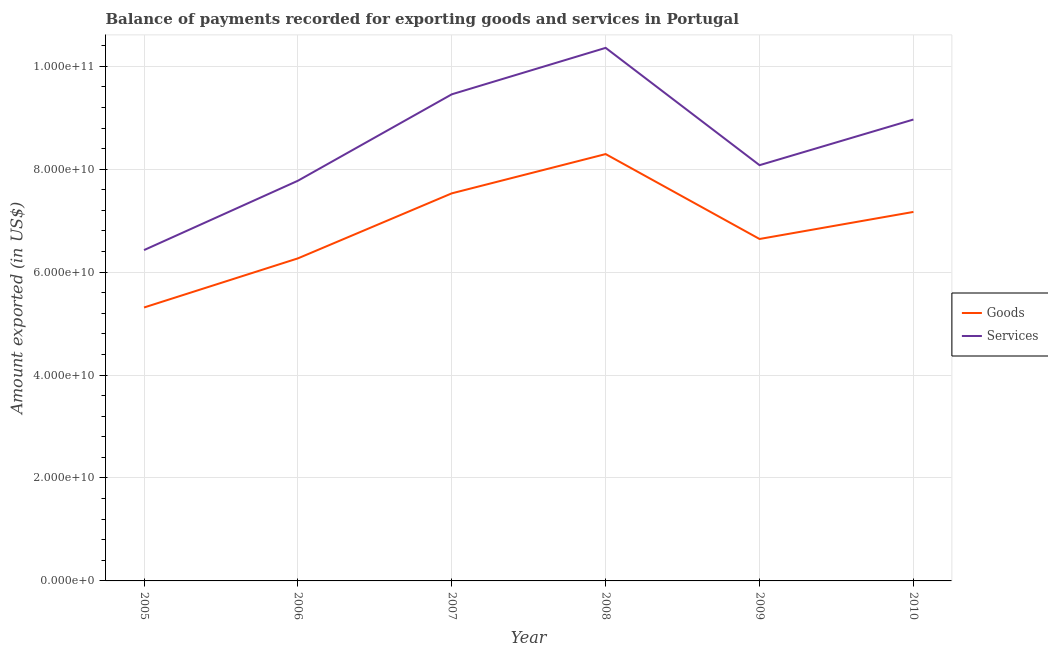How many different coloured lines are there?
Provide a succinct answer. 2. Does the line corresponding to amount of services exported intersect with the line corresponding to amount of goods exported?
Ensure brevity in your answer.  No. What is the amount of goods exported in 2005?
Give a very brief answer. 5.31e+1. Across all years, what is the maximum amount of goods exported?
Offer a very short reply. 8.29e+1. Across all years, what is the minimum amount of goods exported?
Offer a very short reply. 5.31e+1. In which year was the amount of goods exported minimum?
Provide a short and direct response. 2005. What is the total amount of services exported in the graph?
Your answer should be compact. 5.11e+11. What is the difference between the amount of services exported in 2006 and that in 2008?
Give a very brief answer. -2.58e+1. What is the difference between the amount of services exported in 2010 and the amount of goods exported in 2008?
Ensure brevity in your answer.  6.71e+09. What is the average amount of services exported per year?
Ensure brevity in your answer.  8.51e+1. In the year 2005, what is the difference between the amount of goods exported and amount of services exported?
Your response must be concise. -1.12e+1. In how many years, is the amount of services exported greater than 92000000000 US$?
Offer a terse response. 2. What is the ratio of the amount of services exported in 2008 to that in 2010?
Provide a succinct answer. 1.16. Is the difference between the amount of services exported in 2007 and 2009 greater than the difference between the amount of goods exported in 2007 and 2009?
Your answer should be compact. Yes. What is the difference between the highest and the second highest amount of services exported?
Offer a terse response. 9.03e+09. What is the difference between the highest and the lowest amount of services exported?
Offer a very short reply. 3.93e+1. Does the amount of services exported monotonically increase over the years?
Your answer should be compact. No. Is the amount of goods exported strictly greater than the amount of services exported over the years?
Your answer should be compact. No. How many lines are there?
Your answer should be compact. 2. Does the graph contain any zero values?
Your answer should be very brief. No. Does the graph contain grids?
Provide a short and direct response. Yes. Where does the legend appear in the graph?
Ensure brevity in your answer.  Center right. How many legend labels are there?
Keep it short and to the point. 2. How are the legend labels stacked?
Ensure brevity in your answer.  Vertical. What is the title of the graph?
Provide a succinct answer. Balance of payments recorded for exporting goods and services in Portugal. What is the label or title of the Y-axis?
Make the answer very short. Amount exported (in US$). What is the Amount exported (in US$) of Goods in 2005?
Offer a very short reply. 5.31e+1. What is the Amount exported (in US$) in Services in 2005?
Your answer should be very brief. 6.43e+1. What is the Amount exported (in US$) in Goods in 2006?
Your answer should be very brief. 6.27e+1. What is the Amount exported (in US$) of Services in 2006?
Provide a succinct answer. 7.78e+1. What is the Amount exported (in US$) of Goods in 2007?
Make the answer very short. 7.53e+1. What is the Amount exported (in US$) of Services in 2007?
Provide a short and direct response. 9.45e+1. What is the Amount exported (in US$) in Goods in 2008?
Provide a short and direct response. 8.29e+1. What is the Amount exported (in US$) in Services in 2008?
Keep it short and to the point. 1.04e+11. What is the Amount exported (in US$) in Goods in 2009?
Provide a succinct answer. 6.64e+1. What is the Amount exported (in US$) of Services in 2009?
Make the answer very short. 8.08e+1. What is the Amount exported (in US$) in Goods in 2010?
Provide a succinct answer. 7.17e+1. What is the Amount exported (in US$) of Services in 2010?
Your answer should be compact. 8.96e+1. Across all years, what is the maximum Amount exported (in US$) of Goods?
Make the answer very short. 8.29e+1. Across all years, what is the maximum Amount exported (in US$) in Services?
Your response must be concise. 1.04e+11. Across all years, what is the minimum Amount exported (in US$) in Goods?
Give a very brief answer. 5.31e+1. Across all years, what is the minimum Amount exported (in US$) in Services?
Keep it short and to the point. 6.43e+1. What is the total Amount exported (in US$) of Goods in the graph?
Your answer should be very brief. 4.12e+11. What is the total Amount exported (in US$) of Services in the graph?
Your answer should be compact. 5.11e+11. What is the difference between the Amount exported (in US$) of Goods in 2005 and that in 2006?
Offer a very short reply. -9.54e+09. What is the difference between the Amount exported (in US$) in Services in 2005 and that in 2006?
Your answer should be compact. -1.35e+1. What is the difference between the Amount exported (in US$) of Goods in 2005 and that in 2007?
Offer a very short reply. -2.22e+1. What is the difference between the Amount exported (in US$) in Services in 2005 and that in 2007?
Keep it short and to the point. -3.03e+1. What is the difference between the Amount exported (in US$) in Goods in 2005 and that in 2008?
Make the answer very short. -2.98e+1. What is the difference between the Amount exported (in US$) of Services in 2005 and that in 2008?
Ensure brevity in your answer.  -3.93e+1. What is the difference between the Amount exported (in US$) of Goods in 2005 and that in 2009?
Make the answer very short. -1.33e+1. What is the difference between the Amount exported (in US$) of Services in 2005 and that in 2009?
Keep it short and to the point. -1.65e+1. What is the difference between the Amount exported (in US$) in Goods in 2005 and that in 2010?
Your response must be concise. -1.86e+1. What is the difference between the Amount exported (in US$) in Services in 2005 and that in 2010?
Provide a short and direct response. -2.54e+1. What is the difference between the Amount exported (in US$) in Goods in 2006 and that in 2007?
Your answer should be very brief. -1.26e+1. What is the difference between the Amount exported (in US$) in Services in 2006 and that in 2007?
Ensure brevity in your answer.  -1.68e+1. What is the difference between the Amount exported (in US$) of Goods in 2006 and that in 2008?
Your answer should be very brief. -2.03e+1. What is the difference between the Amount exported (in US$) in Services in 2006 and that in 2008?
Your answer should be compact. -2.58e+1. What is the difference between the Amount exported (in US$) of Goods in 2006 and that in 2009?
Give a very brief answer. -3.77e+09. What is the difference between the Amount exported (in US$) in Services in 2006 and that in 2009?
Give a very brief answer. -3.02e+09. What is the difference between the Amount exported (in US$) in Goods in 2006 and that in 2010?
Ensure brevity in your answer.  -9.03e+09. What is the difference between the Amount exported (in US$) in Services in 2006 and that in 2010?
Your answer should be very brief. -1.19e+1. What is the difference between the Amount exported (in US$) of Goods in 2007 and that in 2008?
Keep it short and to the point. -7.63e+09. What is the difference between the Amount exported (in US$) of Services in 2007 and that in 2008?
Keep it short and to the point. -9.03e+09. What is the difference between the Amount exported (in US$) of Goods in 2007 and that in 2009?
Your response must be concise. 8.87e+09. What is the difference between the Amount exported (in US$) in Services in 2007 and that in 2009?
Provide a succinct answer. 1.38e+1. What is the difference between the Amount exported (in US$) in Goods in 2007 and that in 2010?
Your answer should be compact. 3.61e+09. What is the difference between the Amount exported (in US$) of Services in 2007 and that in 2010?
Provide a short and direct response. 4.90e+09. What is the difference between the Amount exported (in US$) of Goods in 2008 and that in 2009?
Keep it short and to the point. 1.65e+1. What is the difference between the Amount exported (in US$) in Services in 2008 and that in 2009?
Provide a short and direct response. 2.28e+1. What is the difference between the Amount exported (in US$) in Goods in 2008 and that in 2010?
Ensure brevity in your answer.  1.12e+1. What is the difference between the Amount exported (in US$) in Services in 2008 and that in 2010?
Your answer should be compact. 1.39e+1. What is the difference between the Amount exported (in US$) of Goods in 2009 and that in 2010?
Your answer should be compact. -5.26e+09. What is the difference between the Amount exported (in US$) in Services in 2009 and that in 2010?
Provide a succinct answer. -8.87e+09. What is the difference between the Amount exported (in US$) of Goods in 2005 and the Amount exported (in US$) of Services in 2006?
Offer a terse response. -2.46e+1. What is the difference between the Amount exported (in US$) in Goods in 2005 and the Amount exported (in US$) in Services in 2007?
Make the answer very short. -4.14e+1. What is the difference between the Amount exported (in US$) in Goods in 2005 and the Amount exported (in US$) in Services in 2008?
Provide a succinct answer. -5.04e+1. What is the difference between the Amount exported (in US$) in Goods in 2005 and the Amount exported (in US$) in Services in 2009?
Provide a succinct answer. -2.77e+1. What is the difference between the Amount exported (in US$) of Goods in 2005 and the Amount exported (in US$) of Services in 2010?
Your answer should be compact. -3.65e+1. What is the difference between the Amount exported (in US$) of Goods in 2006 and the Amount exported (in US$) of Services in 2007?
Your response must be concise. -3.19e+1. What is the difference between the Amount exported (in US$) in Goods in 2006 and the Amount exported (in US$) in Services in 2008?
Your answer should be compact. -4.09e+1. What is the difference between the Amount exported (in US$) in Goods in 2006 and the Amount exported (in US$) in Services in 2009?
Make the answer very short. -1.81e+1. What is the difference between the Amount exported (in US$) of Goods in 2006 and the Amount exported (in US$) of Services in 2010?
Provide a succinct answer. -2.70e+1. What is the difference between the Amount exported (in US$) of Goods in 2007 and the Amount exported (in US$) of Services in 2008?
Your response must be concise. -2.83e+1. What is the difference between the Amount exported (in US$) in Goods in 2007 and the Amount exported (in US$) in Services in 2009?
Ensure brevity in your answer.  -5.47e+09. What is the difference between the Amount exported (in US$) of Goods in 2007 and the Amount exported (in US$) of Services in 2010?
Make the answer very short. -1.43e+1. What is the difference between the Amount exported (in US$) of Goods in 2008 and the Amount exported (in US$) of Services in 2009?
Keep it short and to the point. 2.16e+09. What is the difference between the Amount exported (in US$) in Goods in 2008 and the Amount exported (in US$) in Services in 2010?
Your answer should be very brief. -6.71e+09. What is the difference between the Amount exported (in US$) of Goods in 2009 and the Amount exported (in US$) of Services in 2010?
Make the answer very short. -2.32e+1. What is the average Amount exported (in US$) in Goods per year?
Your answer should be very brief. 6.87e+1. What is the average Amount exported (in US$) in Services per year?
Offer a terse response. 8.51e+1. In the year 2005, what is the difference between the Amount exported (in US$) of Goods and Amount exported (in US$) of Services?
Ensure brevity in your answer.  -1.12e+1. In the year 2006, what is the difference between the Amount exported (in US$) in Goods and Amount exported (in US$) in Services?
Keep it short and to the point. -1.51e+1. In the year 2007, what is the difference between the Amount exported (in US$) of Goods and Amount exported (in US$) of Services?
Offer a very short reply. -1.92e+1. In the year 2008, what is the difference between the Amount exported (in US$) in Goods and Amount exported (in US$) in Services?
Give a very brief answer. -2.06e+1. In the year 2009, what is the difference between the Amount exported (in US$) of Goods and Amount exported (in US$) of Services?
Provide a short and direct response. -1.43e+1. In the year 2010, what is the difference between the Amount exported (in US$) in Goods and Amount exported (in US$) in Services?
Offer a very short reply. -1.80e+1. What is the ratio of the Amount exported (in US$) in Goods in 2005 to that in 2006?
Keep it short and to the point. 0.85. What is the ratio of the Amount exported (in US$) in Services in 2005 to that in 2006?
Provide a succinct answer. 0.83. What is the ratio of the Amount exported (in US$) in Goods in 2005 to that in 2007?
Keep it short and to the point. 0.71. What is the ratio of the Amount exported (in US$) in Services in 2005 to that in 2007?
Ensure brevity in your answer.  0.68. What is the ratio of the Amount exported (in US$) in Goods in 2005 to that in 2008?
Your answer should be very brief. 0.64. What is the ratio of the Amount exported (in US$) of Services in 2005 to that in 2008?
Provide a succinct answer. 0.62. What is the ratio of the Amount exported (in US$) of Goods in 2005 to that in 2009?
Ensure brevity in your answer.  0.8. What is the ratio of the Amount exported (in US$) in Services in 2005 to that in 2009?
Make the answer very short. 0.8. What is the ratio of the Amount exported (in US$) in Goods in 2005 to that in 2010?
Offer a very short reply. 0.74. What is the ratio of the Amount exported (in US$) of Services in 2005 to that in 2010?
Offer a terse response. 0.72. What is the ratio of the Amount exported (in US$) of Goods in 2006 to that in 2007?
Offer a very short reply. 0.83. What is the ratio of the Amount exported (in US$) of Services in 2006 to that in 2007?
Make the answer very short. 0.82. What is the ratio of the Amount exported (in US$) of Goods in 2006 to that in 2008?
Make the answer very short. 0.76. What is the ratio of the Amount exported (in US$) in Services in 2006 to that in 2008?
Provide a succinct answer. 0.75. What is the ratio of the Amount exported (in US$) in Goods in 2006 to that in 2009?
Ensure brevity in your answer.  0.94. What is the ratio of the Amount exported (in US$) of Services in 2006 to that in 2009?
Your answer should be compact. 0.96. What is the ratio of the Amount exported (in US$) of Goods in 2006 to that in 2010?
Provide a short and direct response. 0.87. What is the ratio of the Amount exported (in US$) in Services in 2006 to that in 2010?
Provide a succinct answer. 0.87. What is the ratio of the Amount exported (in US$) of Goods in 2007 to that in 2008?
Offer a very short reply. 0.91. What is the ratio of the Amount exported (in US$) in Services in 2007 to that in 2008?
Offer a terse response. 0.91. What is the ratio of the Amount exported (in US$) of Goods in 2007 to that in 2009?
Provide a short and direct response. 1.13. What is the ratio of the Amount exported (in US$) in Services in 2007 to that in 2009?
Make the answer very short. 1.17. What is the ratio of the Amount exported (in US$) in Goods in 2007 to that in 2010?
Provide a short and direct response. 1.05. What is the ratio of the Amount exported (in US$) of Services in 2007 to that in 2010?
Give a very brief answer. 1.05. What is the ratio of the Amount exported (in US$) in Goods in 2008 to that in 2009?
Keep it short and to the point. 1.25. What is the ratio of the Amount exported (in US$) of Services in 2008 to that in 2009?
Offer a terse response. 1.28. What is the ratio of the Amount exported (in US$) in Goods in 2008 to that in 2010?
Your answer should be very brief. 1.16. What is the ratio of the Amount exported (in US$) of Services in 2008 to that in 2010?
Make the answer very short. 1.16. What is the ratio of the Amount exported (in US$) in Goods in 2009 to that in 2010?
Keep it short and to the point. 0.93. What is the ratio of the Amount exported (in US$) in Services in 2009 to that in 2010?
Your answer should be very brief. 0.9. What is the difference between the highest and the second highest Amount exported (in US$) of Goods?
Your response must be concise. 7.63e+09. What is the difference between the highest and the second highest Amount exported (in US$) in Services?
Your answer should be compact. 9.03e+09. What is the difference between the highest and the lowest Amount exported (in US$) in Goods?
Offer a terse response. 2.98e+1. What is the difference between the highest and the lowest Amount exported (in US$) of Services?
Your answer should be compact. 3.93e+1. 